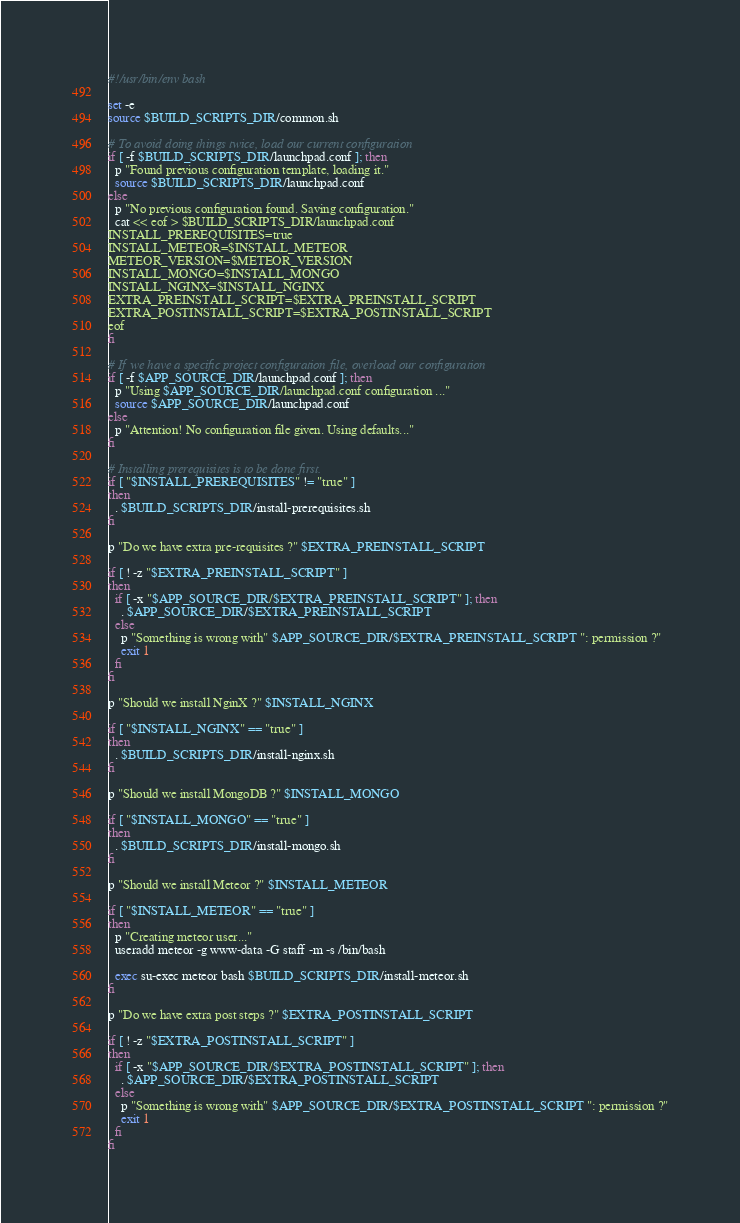<code> <loc_0><loc_0><loc_500><loc_500><_Bash_>#!/usr/bin/env bash

set -e
source $BUILD_SCRIPTS_DIR/common.sh

# To avoid doing things twice, load our current configuration
if [ -f $BUILD_SCRIPTS_DIR/launchpad.conf ]; then
  p "Found previous configuration template, loading it."
  source $BUILD_SCRIPTS_DIR/launchpad.conf
else
  p "No previous configuration found. Saving configuration."
  cat << eof > $BUILD_SCRIPTS_DIR/launchpad.conf
INSTALL_PREREQUISITES=true
INSTALL_METEOR=$INSTALL_METEOR
METEOR_VERSION=$METEOR_VERSION
INSTALL_MONGO=$INSTALL_MONGO
INSTALL_NGINX=$INSTALL_NGINX
EXTRA_PREINSTALL_SCRIPT=$EXTRA_PREINSTALL_SCRIPT
EXTRA_POSTINSTALL_SCRIPT=$EXTRA_POSTINSTALL_SCRIPT
eof
fi

# If we have a specific project configuration file, overload our configuration
if [ -f $APP_SOURCE_DIR/launchpad.conf ]; then
  p "Using $APP_SOURCE_DIR/launchpad.conf configuration ..."
  source $APP_SOURCE_DIR/launchpad.conf
else
  p "Attention! No configuration file given. Using defaults..."
fi

# Installing prerequisites is to be done first.
if [ "$INSTALL_PREREQUISITES" != "true" ]
then
  . $BUILD_SCRIPTS_DIR/install-prerequisites.sh
fi

p "Do we have extra pre-requisites ?" $EXTRA_PREINSTALL_SCRIPT

if [ ! -z "$EXTRA_PREINSTALL_SCRIPT" ]
then
  if [ -x "$APP_SOURCE_DIR/$EXTRA_PREINSTALL_SCRIPT" ]; then
    . $APP_SOURCE_DIR/$EXTRA_PREINSTALL_SCRIPT
  else
    p "Something is wrong with" $APP_SOURCE_DIR/$EXTRA_PREINSTALL_SCRIPT ": permission ?"
    exit 1
  fi
fi

p "Should we install NginX ?" $INSTALL_NGINX

if [ "$INSTALL_NGINX" == "true" ]
then
  . $BUILD_SCRIPTS_DIR/install-nginx.sh
fi

p "Should we install MongoDB ?" $INSTALL_MONGO

if [ "$INSTALL_MONGO" == "true" ]
then
  . $BUILD_SCRIPTS_DIR/install-mongo.sh
fi

p "Should we install Meteor ?" $INSTALL_METEOR

if [ "$INSTALL_METEOR" == "true" ]
then
  p "Creating meteor user..."
  useradd meteor -g www-data -G staff -m -s /bin/bash

  exec su-exec meteor bash $BUILD_SCRIPTS_DIR/install-meteor.sh
fi

p "Do we have extra post steps ?" $EXTRA_POSTINSTALL_SCRIPT

if [ ! -z "$EXTRA_POSTINSTALL_SCRIPT" ]
then
  if [ -x "$APP_SOURCE_DIR/$EXTRA_POSTINSTALL_SCRIPT" ]; then
    . $APP_SOURCE_DIR/$EXTRA_POSTINSTALL_SCRIPT
  else
    p "Something is wrong with" $APP_SOURCE_DIR/$EXTRA_POSTINSTALL_SCRIPT ": permission ?"
    exit 1
  fi
fi
</code> 